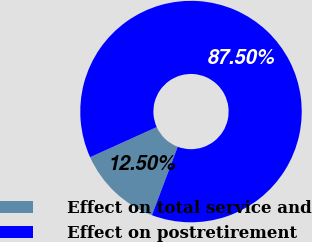<chart> <loc_0><loc_0><loc_500><loc_500><pie_chart><fcel>Effect on total service and<fcel>Effect on postretirement<nl><fcel>12.5%<fcel>87.5%<nl></chart> 